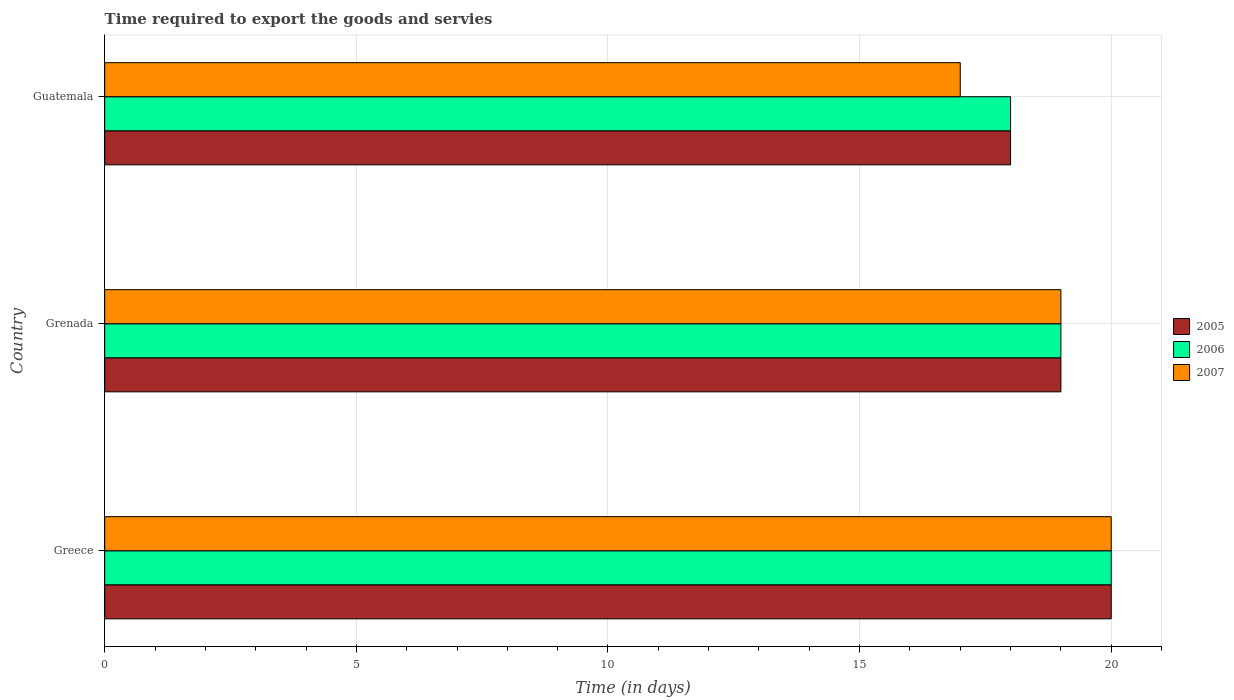Are the number of bars per tick equal to the number of legend labels?
Your response must be concise. Yes. Are the number of bars on each tick of the Y-axis equal?
Your answer should be very brief. Yes. What is the label of the 1st group of bars from the top?
Your answer should be very brief. Guatemala. In how many cases, is the number of bars for a given country not equal to the number of legend labels?
Provide a succinct answer. 0. What is the number of days required to export the goods and services in 2005 in Greece?
Offer a very short reply. 20. Across all countries, what is the maximum number of days required to export the goods and services in 2006?
Your response must be concise. 20. Across all countries, what is the minimum number of days required to export the goods and services in 2006?
Offer a terse response. 18. In which country was the number of days required to export the goods and services in 2005 minimum?
Provide a succinct answer. Guatemala. What is the total number of days required to export the goods and services in 2006 in the graph?
Your answer should be compact. 57. What is the difference between the number of days required to export the goods and services in 2006 in Greece and that in Grenada?
Your answer should be compact. 1. In how many countries, is the number of days required to export the goods and services in 2006 greater than 6 days?
Your answer should be compact. 3. What is the ratio of the number of days required to export the goods and services in 2007 in Greece to that in Guatemala?
Your response must be concise. 1.18. Is the sum of the number of days required to export the goods and services in 2007 in Grenada and Guatemala greater than the maximum number of days required to export the goods and services in 2005 across all countries?
Provide a short and direct response. Yes. What does the 1st bar from the top in Greece represents?
Give a very brief answer. 2007. What does the 2nd bar from the bottom in Guatemala represents?
Offer a terse response. 2006. How many bars are there?
Your response must be concise. 9. Are all the bars in the graph horizontal?
Give a very brief answer. Yes. How many countries are there in the graph?
Provide a short and direct response. 3. What is the difference between two consecutive major ticks on the X-axis?
Your answer should be compact. 5. Are the values on the major ticks of X-axis written in scientific E-notation?
Make the answer very short. No. Does the graph contain any zero values?
Your answer should be very brief. No. Where does the legend appear in the graph?
Your answer should be compact. Center right. What is the title of the graph?
Keep it short and to the point. Time required to export the goods and servies. What is the label or title of the X-axis?
Make the answer very short. Time (in days). What is the label or title of the Y-axis?
Offer a very short reply. Country. What is the Time (in days) in 2005 in Greece?
Keep it short and to the point. 20. What is the Time (in days) in 2005 in Grenada?
Keep it short and to the point. 19. What is the Time (in days) in 2006 in Grenada?
Keep it short and to the point. 19. What is the Time (in days) of 2005 in Guatemala?
Keep it short and to the point. 18. What is the Time (in days) in 2007 in Guatemala?
Your answer should be compact. 17. Across all countries, what is the maximum Time (in days) in 2006?
Provide a succinct answer. 20. Across all countries, what is the minimum Time (in days) in 2006?
Your answer should be very brief. 18. Across all countries, what is the minimum Time (in days) of 2007?
Provide a short and direct response. 17. What is the total Time (in days) of 2005 in the graph?
Offer a very short reply. 57. What is the total Time (in days) of 2006 in the graph?
Your answer should be very brief. 57. What is the difference between the Time (in days) of 2005 in Greece and that in Grenada?
Keep it short and to the point. 1. What is the difference between the Time (in days) of 2006 in Greece and that in Grenada?
Keep it short and to the point. 1. What is the difference between the Time (in days) of 2007 in Greece and that in Grenada?
Ensure brevity in your answer.  1. What is the difference between the Time (in days) of 2005 in Greece and the Time (in days) of 2006 in Guatemala?
Make the answer very short. 2. What is the difference between the Time (in days) in 2005 in Grenada and the Time (in days) in 2006 in Guatemala?
Your answer should be compact. 1. What is the difference between the Time (in days) of 2005 in Grenada and the Time (in days) of 2007 in Guatemala?
Offer a terse response. 2. What is the average Time (in days) in 2005 per country?
Provide a succinct answer. 19. What is the average Time (in days) in 2007 per country?
Offer a terse response. 18.67. What is the difference between the Time (in days) of 2005 and Time (in days) of 2006 in Greece?
Provide a short and direct response. 0. What is the difference between the Time (in days) in 2005 and Time (in days) in 2006 in Grenada?
Your answer should be compact. 0. What is the difference between the Time (in days) of 2006 and Time (in days) of 2007 in Guatemala?
Offer a very short reply. 1. What is the ratio of the Time (in days) of 2005 in Greece to that in Grenada?
Make the answer very short. 1.05. What is the ratio of the Time (in days) of 2006 in Greece to that in Grenada?
Offer a terse response. 1.05. What is the ratio of the Time (in days) of 2007 in Greece to that in Grenada?
Give a very brief answer. 1.05. What is the ratio of the Time (in days) of 2007 in Greece to that in Guatemala?
Offer a terse response. 1.18. What is the ratio of the Time (in days) of 2005 in Grenada to that in Guatemala?
Ensure brevity in your answer.  1.06. What is the ratio of the Time (in days) of 2006 in Grenada to that in Guatemala?
Provide a short and direct response. 1.06. What is the ratio of the Time (in days) in 2007 in Grenada to that in Guatemala?
Keep it short and to the point. 1.12. What is the difference between the highest and the second highest Time (in days) in 2005?
Ensure brevity in your answer.  1. What is the difference between the highest and the second highest Time (in days) of 2007?
Keep it short and to the point. 1. What is the difference between the highest and the lowest Time (in days) of 2006?
Ensure brevity in your answer.  2. 